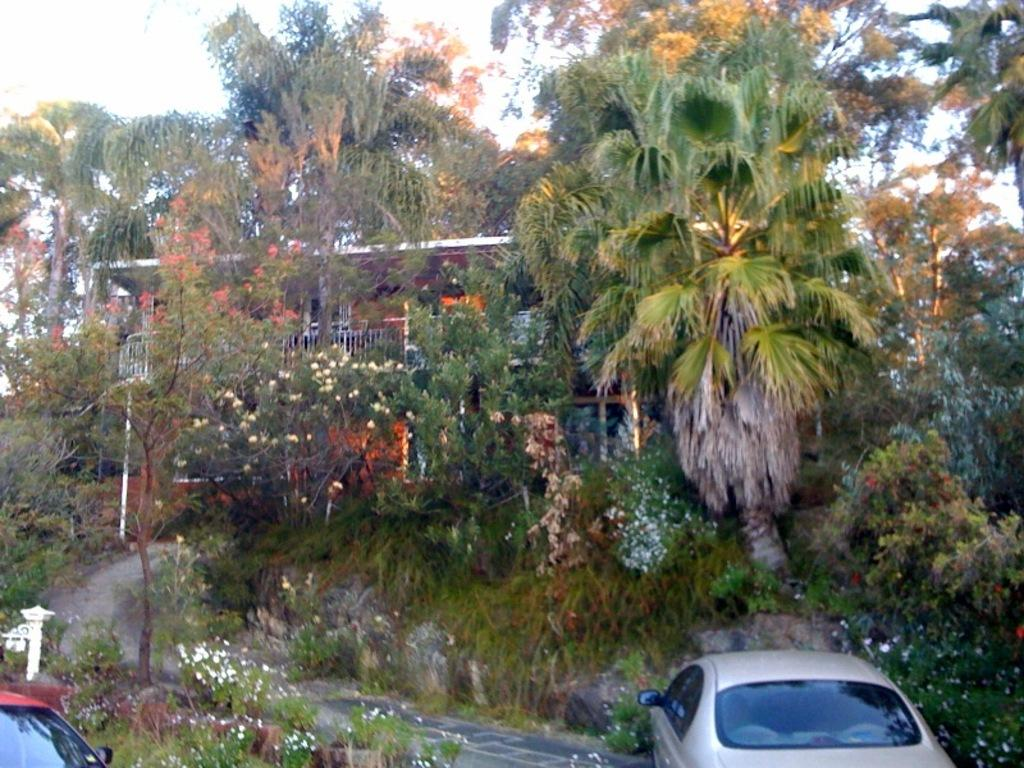What can be found in the parking space in the image? There are vehicles in the parking space in the image. What type of vegetation is visible in the image? Flower plants and trees are present in the image. What is the purpose of the walkway in the image? The walkway in the image provides a path for people to walk on. What type of structure is visible in the image? There is a house in the image. What is visible in the sky in the image? Clouds are visible in the sky in the image. Reasoning: Let'g: Let's think step by step in order to produce the conversation. We start by identifying the main subjects and objects in the image based on the provided facts. We then formulate questions that focus on the location and characteristics of these subjects and objects, ensuring that each question can be answered definitively with the information given. We avoid yes/no questions and ensure that the language is simple and clear. Absurd Question/Answer: What type of band can be heard playing music in the image? A: There is no band present in the image, so no music can be heard. How many frogs are visible in the image? There are no frogs visible in the image. What type of substance is being used to clean the vehicles in the image? There is no indication in the image that any substance is being used to clean the vehicles. 